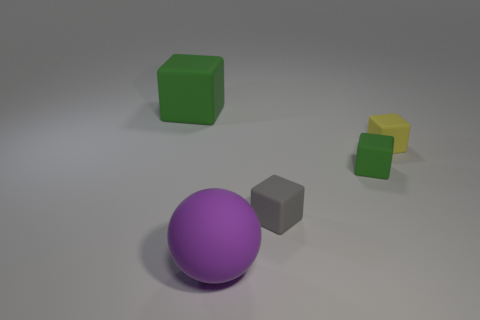Add 1 tiny blue shiny blocks. How many objects exist? 6 Subtract all cubes. How many objects are left? 1 Subtract 0 purple blocks. How many objects are left? 5 Subtract all big blocks. Subtract all small cubes. How many objects are left? 1 Add 1 large purple rubber balls. How many large purple rubber balls are left? 2 Add 2 red things. How many red things exist? 2 